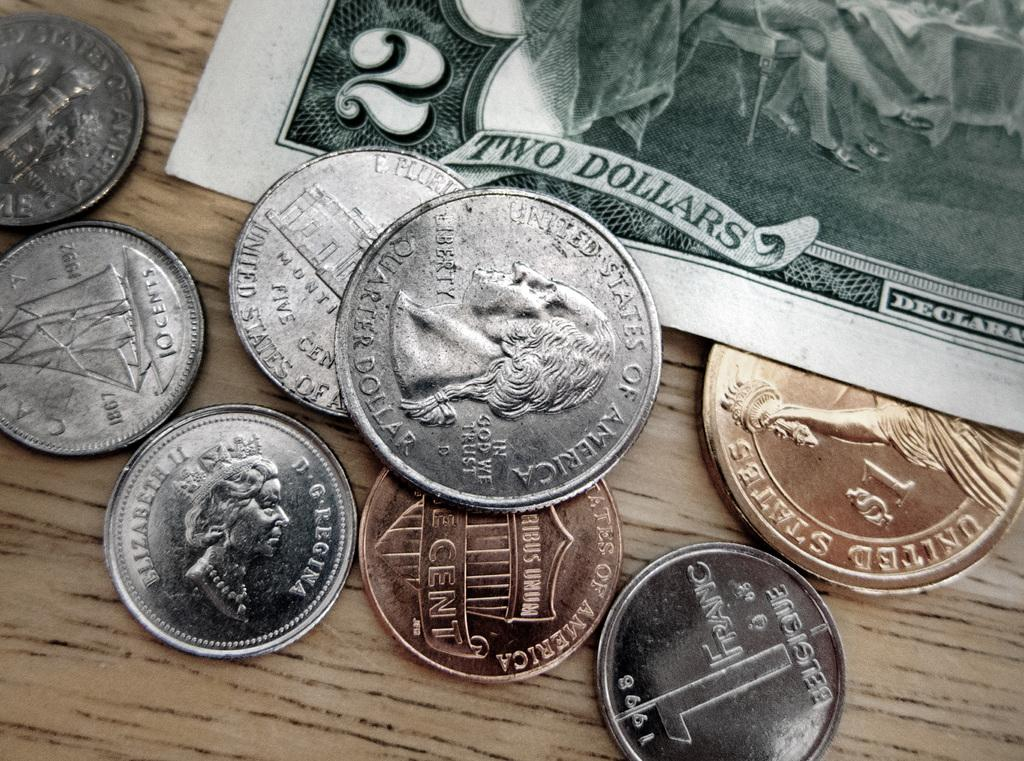<image>
Create a compact narrative representing the image presented. Various coins laying on a surface next to a Two Dollars bill 